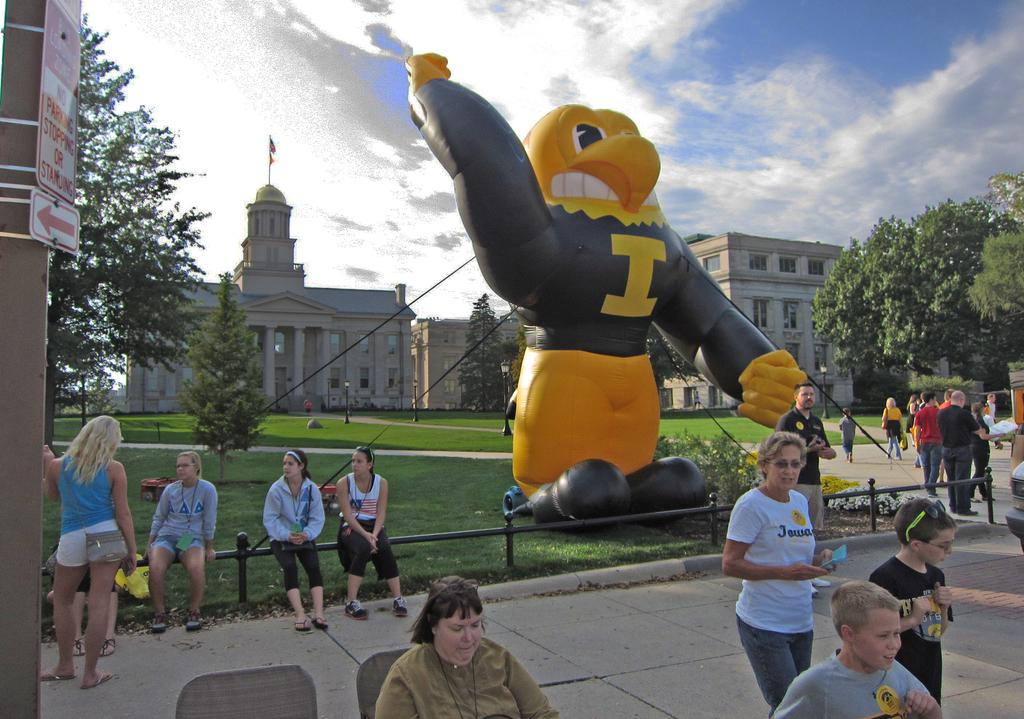<image>
Render a clear and concise summary of the photo. Group of people near a balloon of a mascot that has the letter "I" on it. 